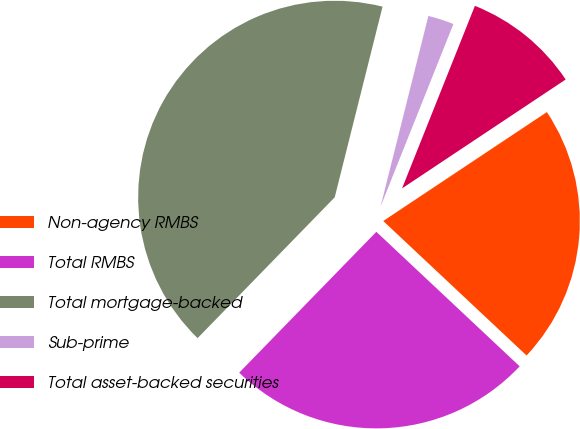Convert chart to OTSL. <chart><loc_0><loc_0><loc_500><loc_500><pie_chart><fcel>Non-agency RMBS<fcel>Total RMBS<fcel>Total mortgage-backed<fcel>Sub-prime<fcel>Total asset-backed securities<nl><fcel>21.34%<fcel>25.29%<fcel>41.62%<fcel>2.13%<fcel>9.61%<nl></chart> 